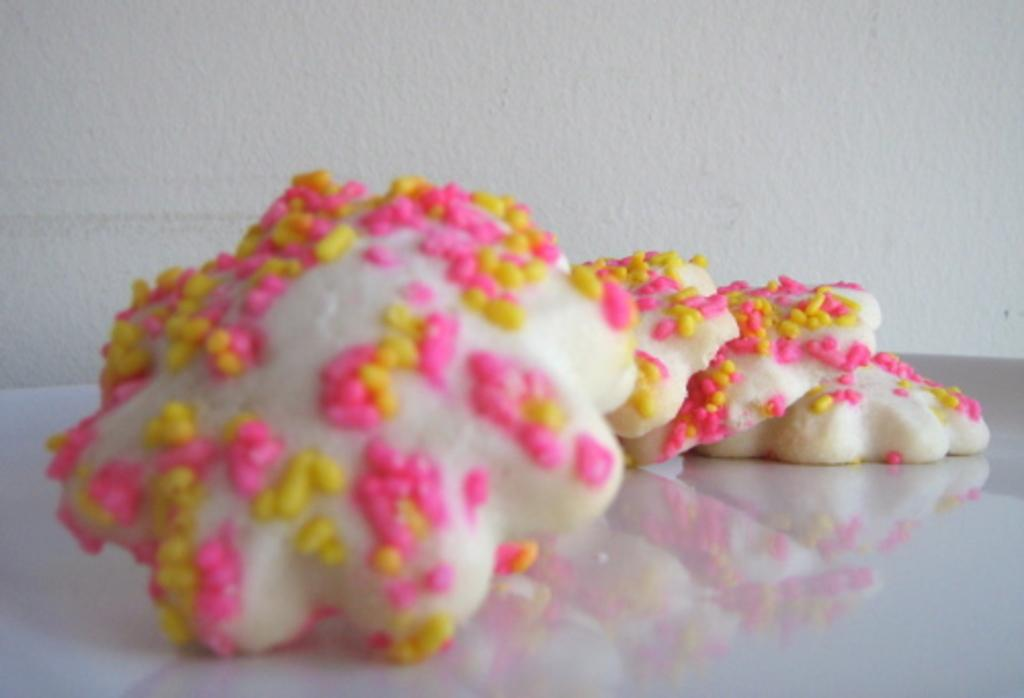What is on the platform in the image? There is food on a platform in the image. What color is the background of the image? The background of the image is white. What route does the pen take to reach the sail in the image? There is no pen or sail present in the image, so it is not possible to determine a route. 